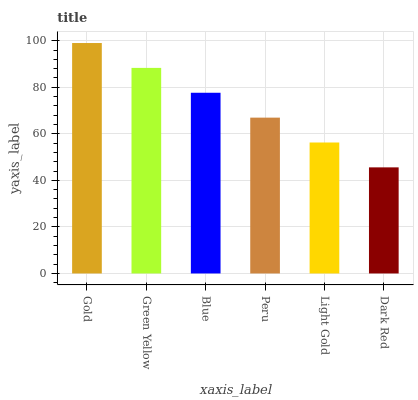Is Dark Red the minimum?
Answer yes or no. Yes. Is Gold the maximum?
Answer yes or no. Yes. Is Green Yellow the minimum?
Answer yes or no. No. Is Green Yellow the maximum?
Answer yes or no. No. Is Gold greater than Green Yellow?
Answer yes or no. Yes. Is Green Yellow less than Gold?
Answer yes or no. Yes. Is Green Yellow greater than Gold?
Answer yes or no. No. Is Gold less than Green Yellow?
Answer yes or no. No. Is Blue the high median?
Answer yes or no. Yes. Is Peru the low median?
Answer yes or no. Yes. Is Light Gold the high median?
Answer yes or no. No. Is Dark Red the low median?
Answer yes or no. No. 